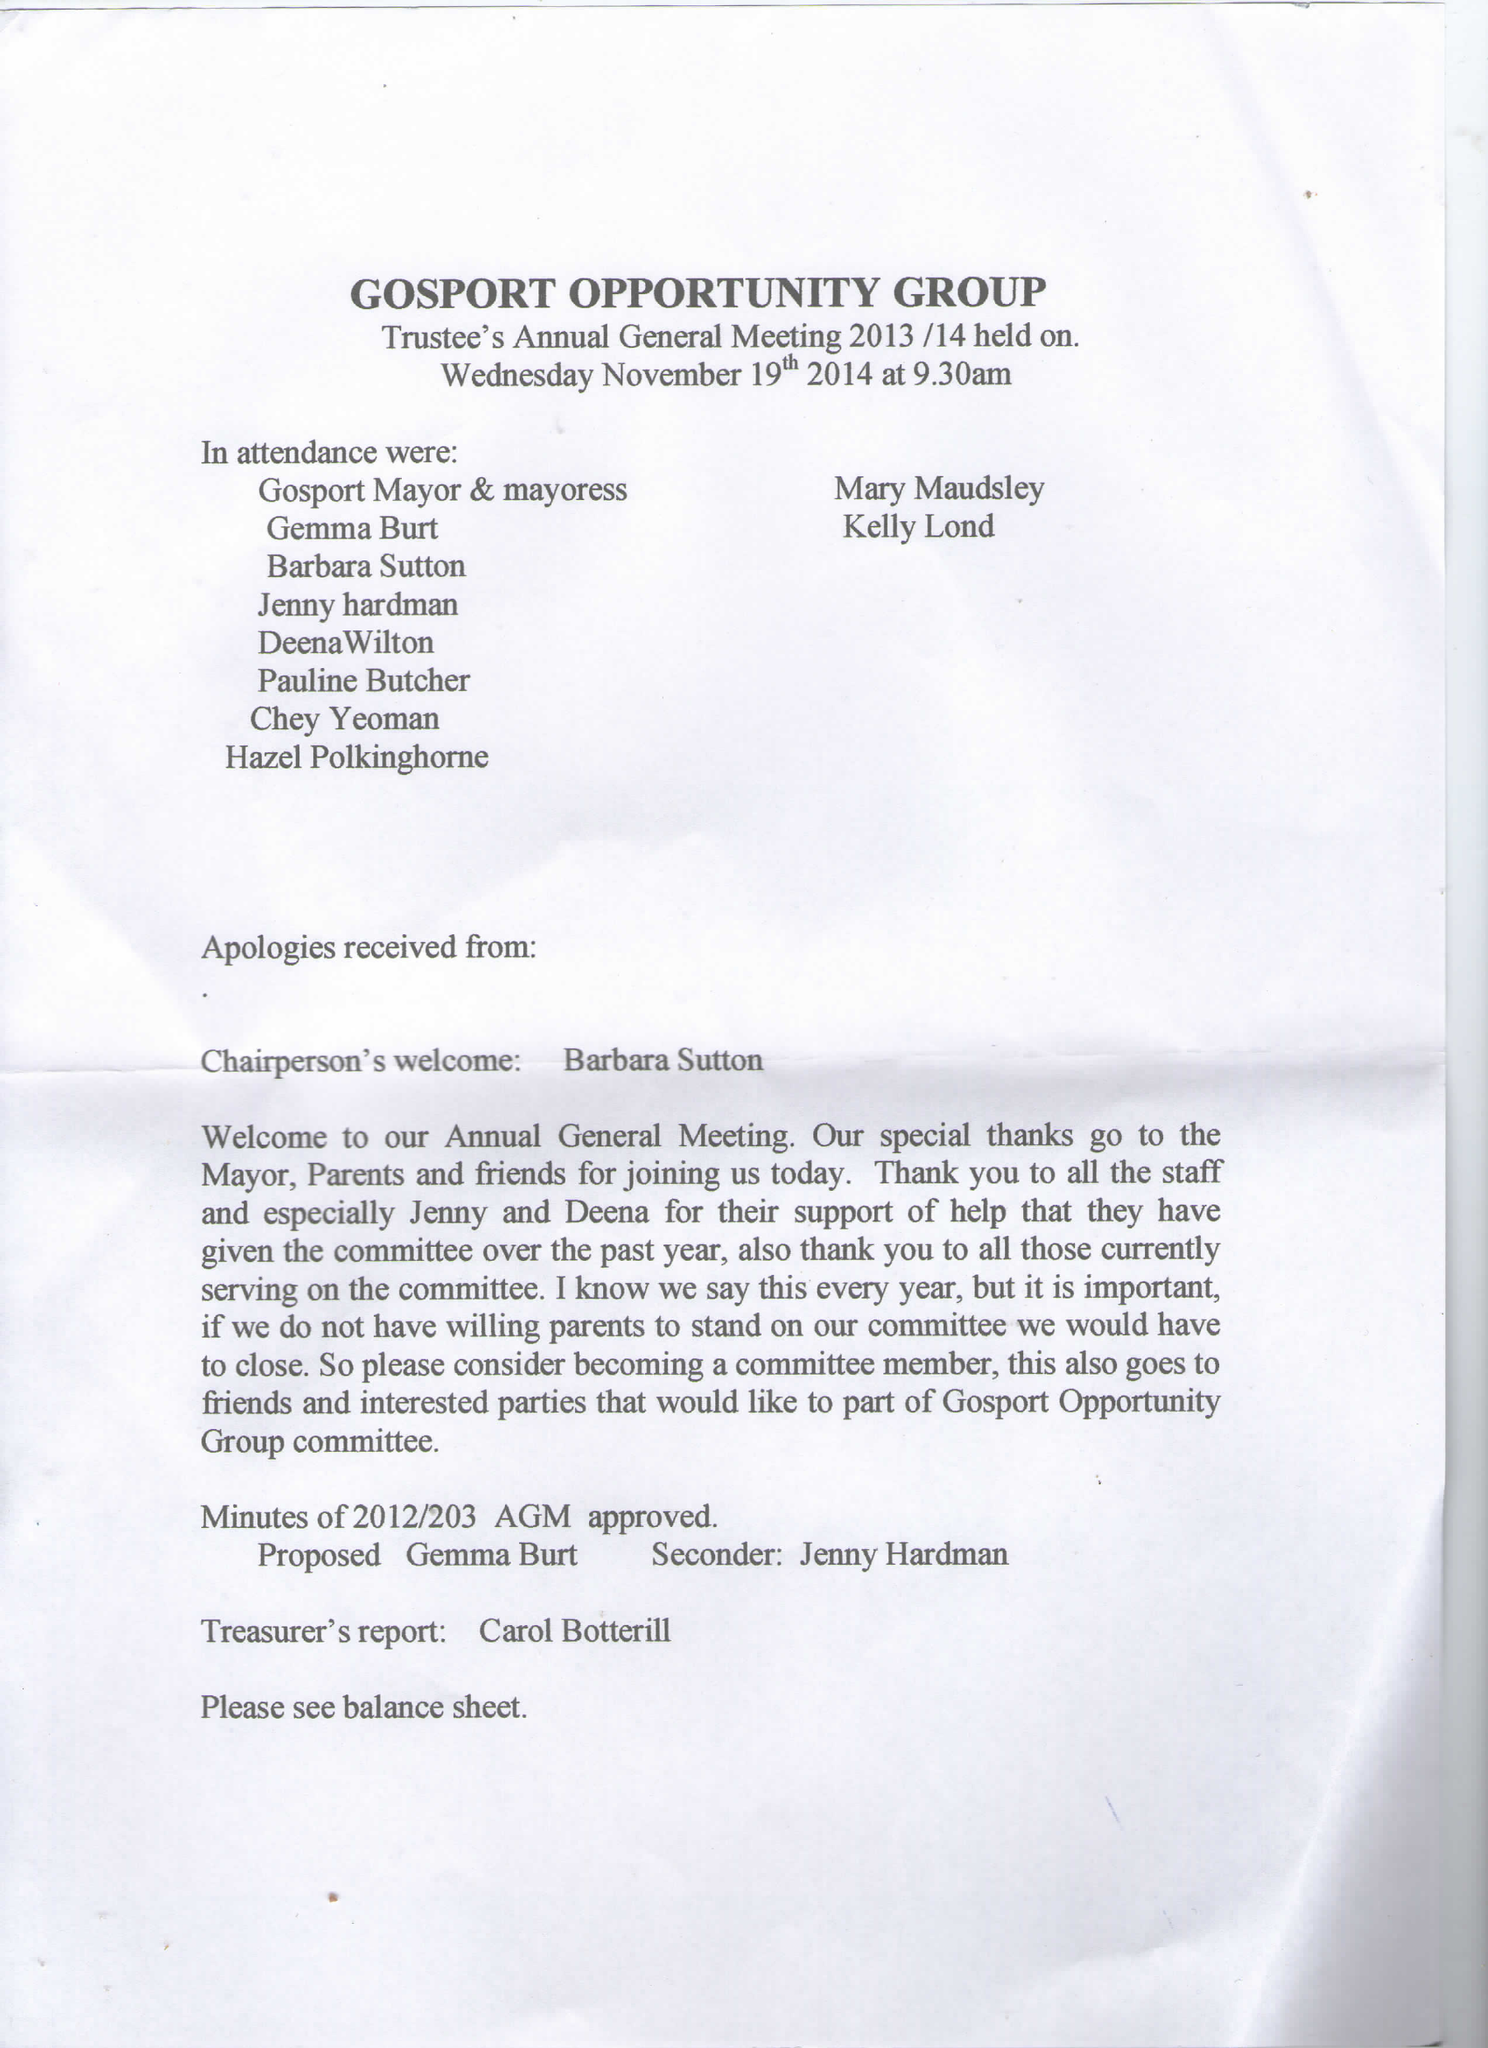What is the value for the report_date?
Answer the question using a single word or phrase. 2015-08-31 